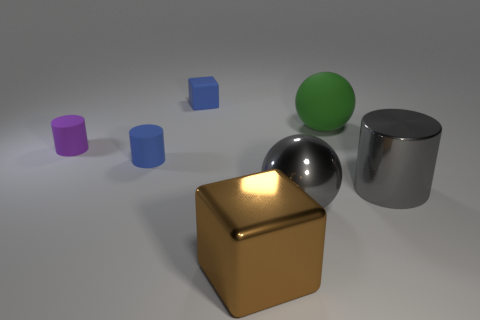What material is the big thing that is behind the cylinder right of the block to the right of the blue block? The large object behind the cylinder to the right of the block that is to the right of the blue block appears to be made of a shiny, reflective metal. This can be inferred from its reflective surface and the way it casts reflections and highlights, which are typical characteristics of polished metal materials. 